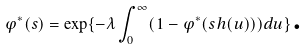<formula> <loc_0><loc_0><loc_500><loc_500>\varphi ^ { \ast } ( s ) = \exp \{ - \lambda \int _ { 0 } ^ { \infty } ( 1 - \varphi ^ { \ast } ( s h ( u ) ) ) d u \} \text {.}</formula> 